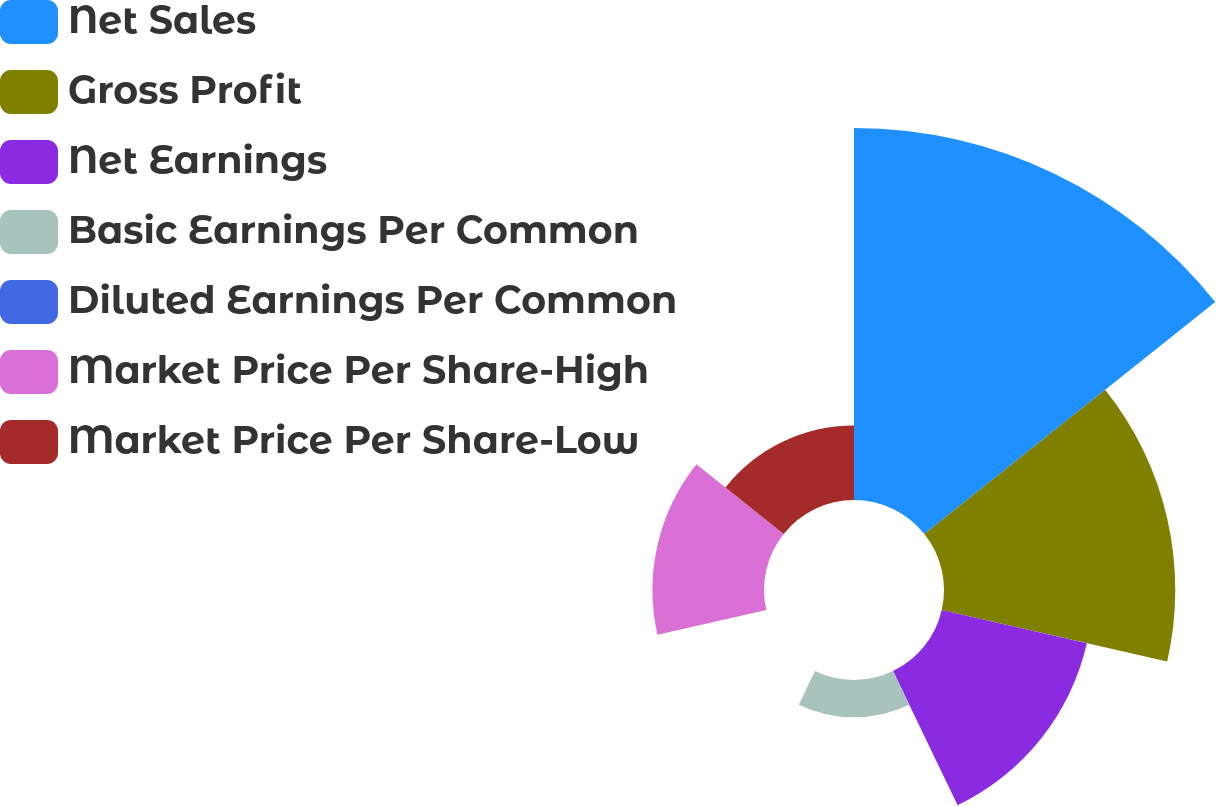<chart> <loc_0><loc_0><loc_500><loc_500><pie_chart><fcel>Net Sales<fcel>Gross Profit<fcel>Net Earnings<fcel>Basic Earnings Per Common<fcel>Diluted Earnings Per Common<fcel>Market Price Per Share-High<fcel>Market Price Per Share-Low<nl><fcel>38.14%<fcel>23.71%<fcel>15.26%<fcel>3.82%<fcel>0.0%<fcel>11.44%<fcel>7.63%<nl></chart> 